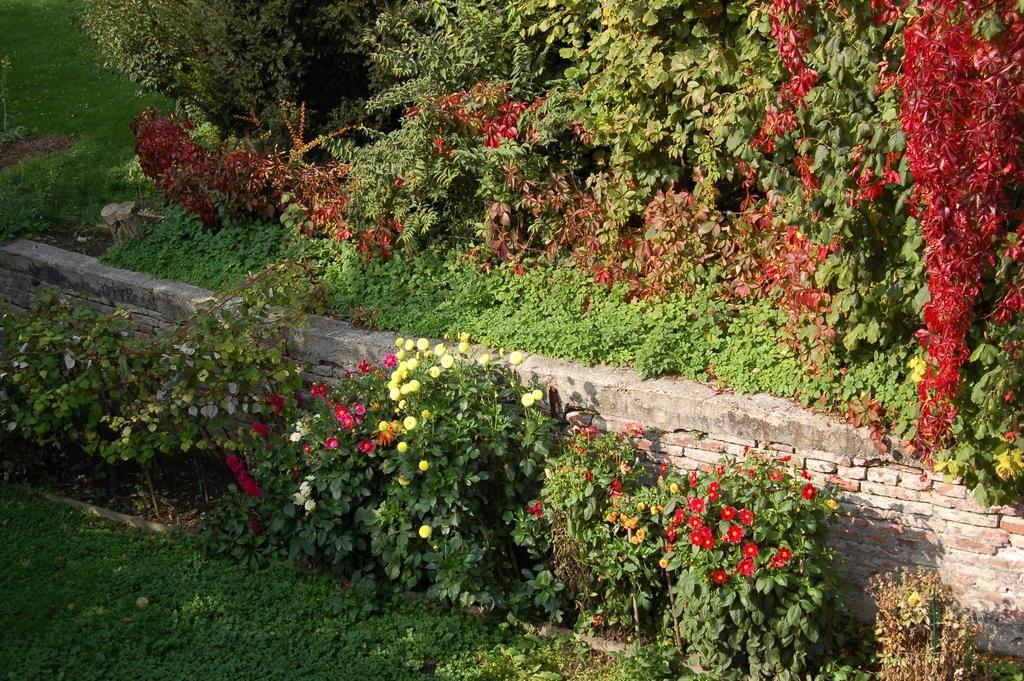Please provide a concise description of this image. In this picture we can see plants with flowers. Behind the plants there is a wall, trees and grass. 